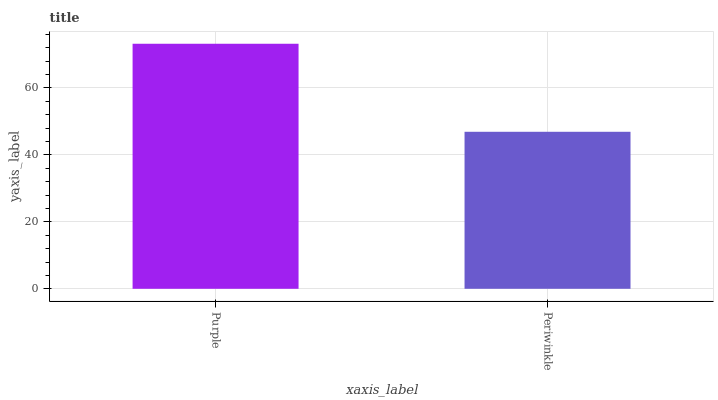Is Periwinkle the maximum?
Answer yes or no. No. Is Purple greater than Periwinkle?
Answer yes or no. Yes. Is Periwinkle less than Purple?
Answer yes or no. Yes. Is Periwinkle greater than Purple?
Answer yes or no. No. Is Purple less than Periwinkle?
Answer yes or no. No. Is Purple the high median?
Answer yes or no. Yes. Is Periwinkle the low median?
Answer yes or no. Yes. Is Periwinkle the high median?
Answer yes or no. No. Is Purple the low median?
Answer yes or no. No. 